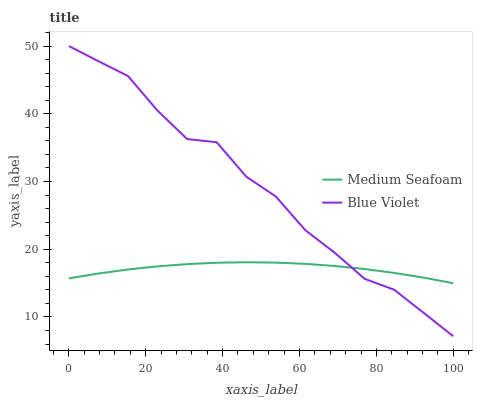Does Medium Seafoam have the minimum area under the curve?
Answer yes or no. Yes. Does Blue Violet have the maximum area under the curve?
Answer yes or no. Yes. Does Blue Violet have the minimum area under the curve?
Answer yes or no. No. Is Medium Seafoam the smoothest?
Answer yes or no. Yes. Is Blue Violet the roughest?
Answer yes or no. Yes. Is Blue Violet the smoothest?
Answer yes or no. No. Does Blue Violet have the lowest value?
Answer yes or no. Yes. Does Blue Violet have the highest value?
Answer yes or no. Yes. Does Blue Violet intersect Medium Seafoam?
Answer yes or no. Yes. Is Blue Violet less than Medium Seafoam?
Answer yes or no. No. Is Blue Violet greater than Medium Seafoam?
Answer yes or no. No. 